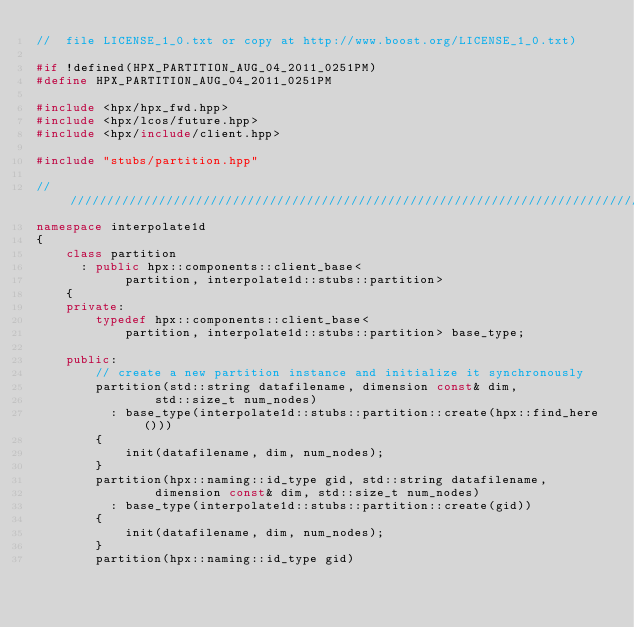<code> <loc_0><loc_0><loc_500><loc_500><_C++_>//  file LICENSE_1_0.txt or copy at http://www.boost.org/LICENSE_1_0.txt)

#if !defined(HPX_PARTITION_AUG_04_2011_0251PM)
#define HPX_PARTITION_AUG_04_2011_0251PM

#include <hpx/hpx_fwd.hpp>
#include <hpx/lcos/future.hpp>
#include <hpx/include/client.hpp>

#include "stubs/partition.hpp"

///////////////////////////////////////////////////////////////////////////////
namespace interpolate1d
{
    class partition
      : public hpx::components::client_base<
            partition, interpolate1d::stubs::partition>
    {
    private:
        typedef hpx::components::client_base<
            partition, interpolate1d::stubs::partition> base_type;

    public:
        // create a new partition instance and initialize it synchronously
        partition(std::string datafilename, dimension const& dim,
                std::size_t num_nodes)
          : base_type(interpolate1d::stubs::partition::create(hpx::find_here()))
        {
            init(datafilename, dim, num_nodes);
        }
        partition(hpx::naming::id_type gid, std::string datafilename,
                dimension const& dim, std::size_t num_nodes)
          : base_type(interpolate1d::stubs::partition::create(gid))
        {
            init(datafilename, dim, num_nodes);
        }
        partition(hpx::naming::id_type gid)</code> 